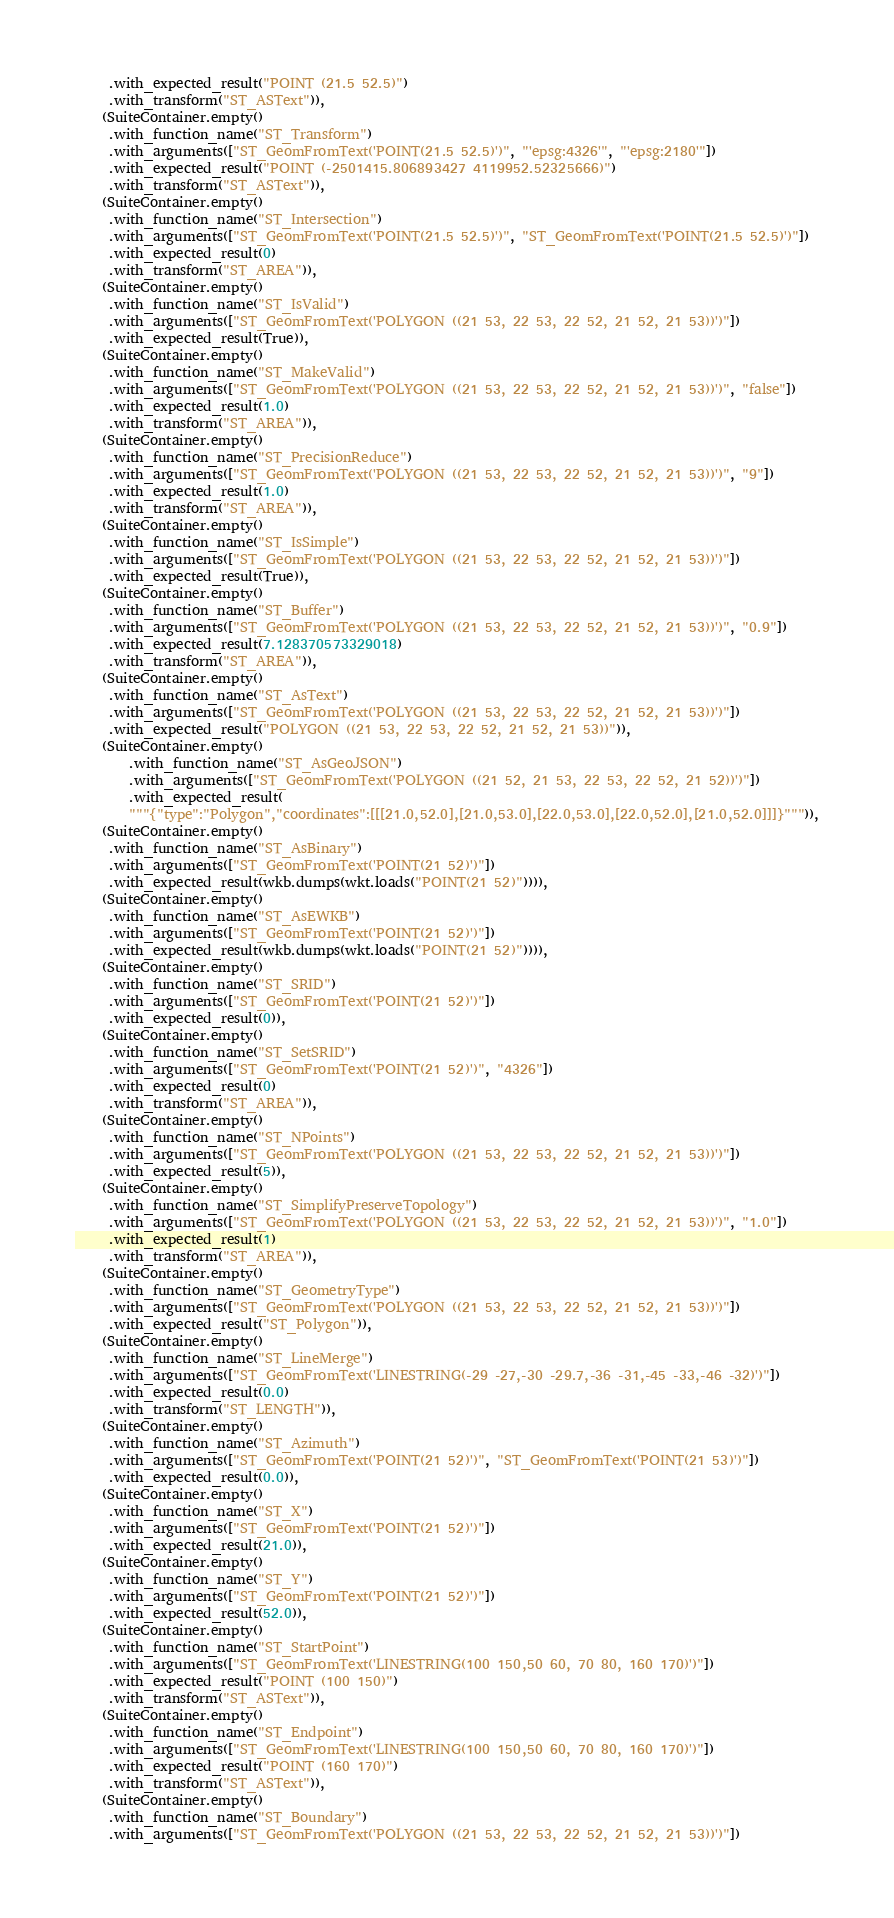Convert code to text. <code><loc_0><loc_0><loc_500><loc_500><_Python_>     .with_expected_result("POINT (21.5 52.5)")
     .with_transform("ST_ASText")),
    (SuiteContainer.empty()
     .with_function_name("ST_Transform")
     .with_arguments(["ST_GeomFromText('POINT(21.5 52.5)')", "'epsg:4326'", "'epsg:2180'"])
     .with_expected_result("POINT (-2501415.806893427 4119952.52325666)")
     .with_transform("ST_ASText")),
    (SuiteContainer.empty()
     .with_function_name("ST_Intersection")
     .with_arguments(["ST_GeomFromText('POINT(21.5 52.5)')", "ST_GeomFromText('POINT(21.5 52.5)')"])
     .with_expected_result(0)
     .with_transform("ST_AREA")),
    (SuiteContainer.empty()
     .with_function_name("ST_IsValid")
     .with_arguments(["ST_GeomFromText('POLYGON ((21 53, 22 53, 22 52, 21 52, 21 53))')"])
     .with_expected_result(True)),
    (SuiteContainer.empty()
     .with_function_name("ST_MakeValid")
     .with_arguments(["ST_GeomFromText('POLYGON ((21 53, 22 53, 22 52, 21 52, 21 53))')", "false"])
     .with_expected_result(1.0)
     .with_transform("ST_AREA")),
    (SuiteContainer.empty()
     .with_function_name("ST_PrecisionReduce")
     .with_arguments(["ST_GeomFromText('POLYGON ((21 53, 22 53, 22 52, 21 52, 21 53))')", "9"])
     .with_expected_result(1.0)
     .with_transform("ST_AREA")),
    (SuiteContainer.empty()
     .with_function_name("ST_IsSimple")
     .with_arguments(["ST_GeomFromText('POLYGON ((21 53, 22 53, 22 52, 21 52, 21 53))')"])
     .with_expected_result(True)),
    (SuiteContainer.empty()
     .with_function_name("ST_Buffer")
     .with_arguments(["ST_GeomFromText('POLYGON ((21 53, 22 53, 22 52, 21 52, 21 53))')", "0.9"])
     .with_expected_result(7.128370573329018)
     .with_transform("ST_AREA")),
    (SuiteContainer.empty()
     .with_function_name("ST_AsText")
     .with_arguments(["ST_GeomFromText('POLYGON ((21 53, 22 53, 22 52, 21 52, 21 53))')"])
     .with_expected_result("POLYGON ((21 53, 22 53, 22 52, 21 52, 21 53))")),
    (SuiteContainer.empty()
        .with_function_name("ST_AsGeoJSON")
        .with_arguments(["ST_GeomFromText('POLYGON ((21 52, 21 53, 22 53, 22 52, 21 52))')"])
        .with_expected_result(
        """{"type":"Polygon","coordinates":[[[21.0,52.0],[21.0,53.0],[22.0,53.0],[22.0,52.0],[21.0,52.0]]]}""")),
    (SuiteContainer.empty()
     .with_function_name("ST_AsBinary")
     .with_arguments(["ST_GeomFromText('POINT(21 52)')"])
     .with_expected_result(wkb.dumps(wkt.loads("POINT(21 52)")))),
    (SuiteContainer.empty()
     .with_function_name("ST_AsEWKB")
     .with_arguments(["ST_GeomFromText('POINT(21 52)')"])
     .with_expected_result(wkb.dumps(wkt.loads("POINT(21 52)")))),
    (SuiteContainer.empty()
     .with_function_name("ST_SRID")
     .with_arguments(["ST_GeomFromText('POINT(21 52)')"])
     .with_expected_result(0)),
    (SuiteContainer.empty()
     .with_function_name("ST_SetSRID")
     .with_arguments(["ST_GeomFromText('POINT(21 52)')", "4326"])
     .with_expected_result(0)
     .with_transform("ST_AREA")),
    (SuiteContainer.empty()
     .with_function_name("ST_NPoints")
     .with_arguments(["ST_GeomFromText('POLYGON ((21 53, 22 53, 22 52, 21 52, 21 53))')"])
     .with_expected_result(5)),
    (SuiteContainer.empty()
     .with_function_name("ST_SimplifyPreserveTopology")
     .with_arguments(["ST_GeomFromText('POLYGON ((21 53, 22 53, 22 52, 21 52, 21 53))')", "1.0"])
     .with_expected_result(1)
     .with_transform("ST_AREA")),
    (SuiteContainer.empty()
     .with_function_name("ST_GeometryType")
     .with_arguments(["ST_GeomFromText('POLYGON ((21 53, 22 53, 22 52, 21 52, 21 53))')"])
     .with_expected_result("ST_Polygon")),
    (SuiteContainer.empty()
     .with_function_name("ST_LineMerge")
     .with_arguments(["ST_GeomFromText('LINESTRING(-29 -27,-30 -29.7,-36 -31,-45 -33,-46 -32)')"])
     .with_expected_result(0.0)
     .with_transform("ST_LENGTH")),
    (SuiteContainer.empty()
     .with_function_name("ST_Azimuth")
     .with_arguments(["ST_GeomFromText('POINT(21 52)')", "ST_GeomFromText('POINT(21 53)')"])
     .with_expected_result(0.0)),
    (SuiteContainer.empty()
     .with_function_name("ST_X")
     .with_arguments(["ST_GeomFromText('POINT(21 52)')"])
     .with_expected_result(21.0)),
    (SuiteContainer.empty()
     .with_function_name("ST_Y")
     .with_arguments(["ST_GeomFromText('POINT(21 52)')"])
     .with_expected_result(52.0)),
    (SuiteContainer.empty()
     .with_function_name("ST_StartPoint")
     .with_arguments(["ST_GeomFromText('LINESTRING(100 150,50 60, 70 80, 160 170)')"])
     .with_expected_result("POINT (100 150)")
     .with_transform("ST_ASText")),
    (SuiteContainer.empty()
     .with_function_name("ST_Endpoint")
     .with_arguments(["ST_GeomFromText('LINESTRING(100 150,50 60, 70 80, 160 170)')"])
     .with_expected_result("POINT (160 170)")
     .with_transform("ST_ASText")),
    (SuiteContainer.empty()
     .with_function_name("ST_Boundary")
     .with_arguments(["ST_GeomFromText('POLYGON ((21 53, 22 53, 22 52, 21 52, 21 53))')"])</code> 